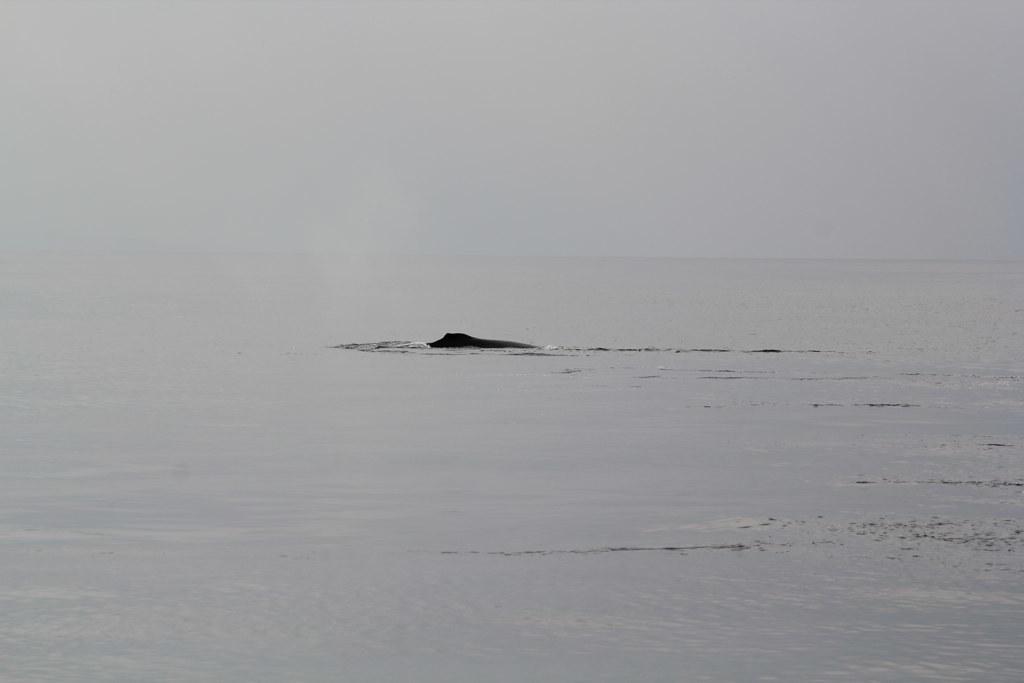Describe this image in one or two sentences. In the image we can see the water and the sky. 